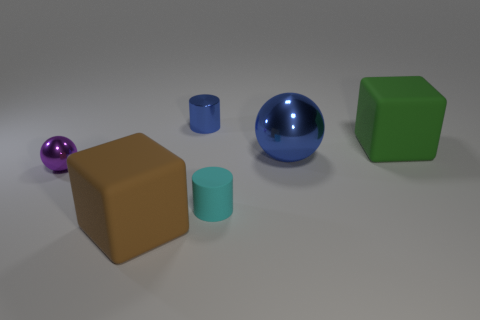Add 3 cyan cylinders. How many objects exist? 9 Subtract all spheres. How many objects are left? 4 Subtract all tiny yellow shiny things. Subtract all big blocks. How many objects are left? 4 Add 2 cyan rubber cylinders. How many cyan rubber cylinders are left? 3 Add 1 large yellow metal cubes. How many large yellow metal cubes exist? 1 Subtract 0 green cylinders. How many objects are left? 6 